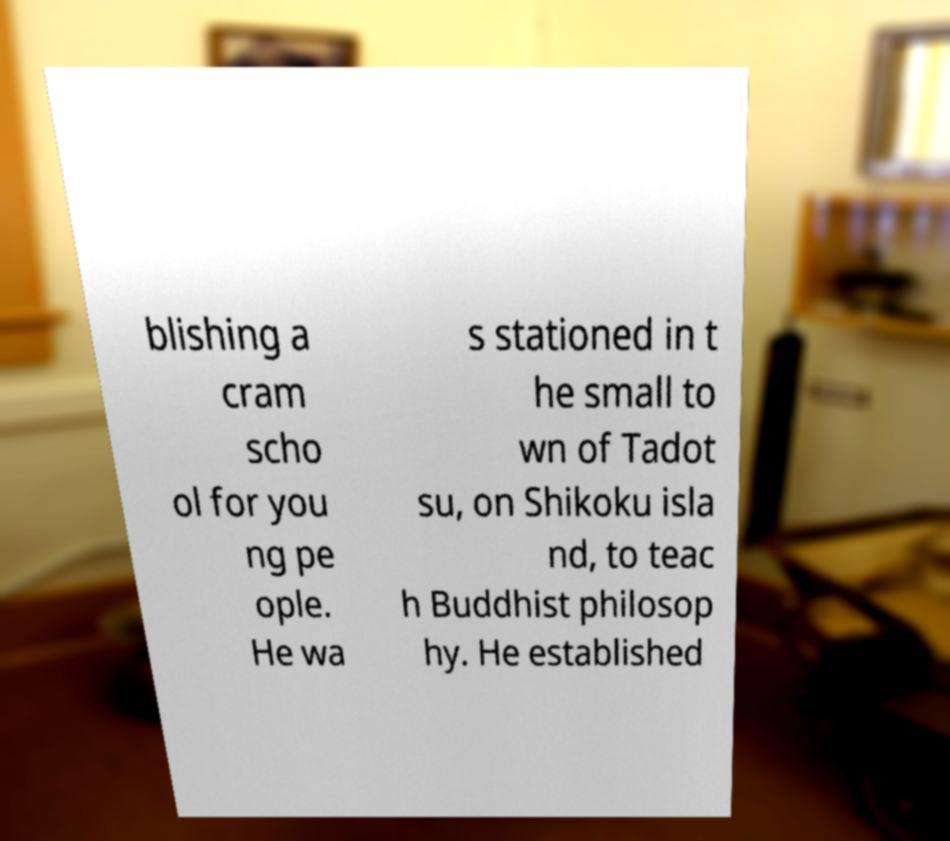Can you accurately transcribe the text from the provided image for me? blishing a cram scho ol for you ng pe ople. He wa s stationed in t he small to wn of Tadot su, on Shikoku isla nd, to teac h Buddhist philosop hy. He established 